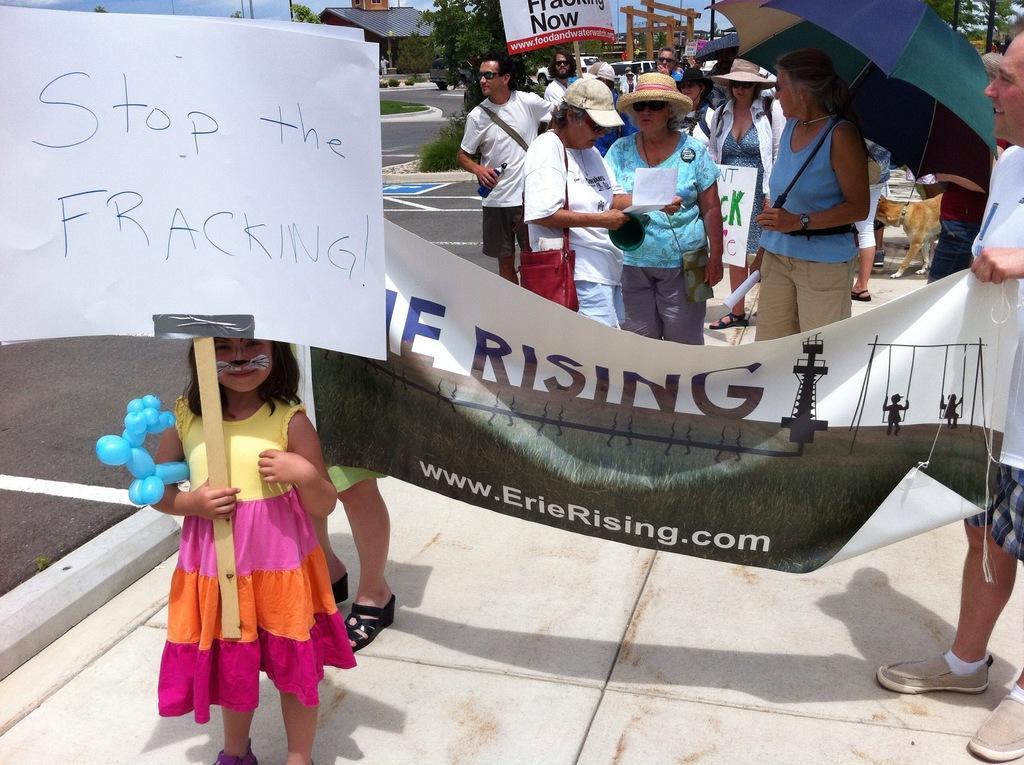Describe this image in one or two sentences. In the image few people are standing and holding some banners and umbrellas and papers. Behind them there are some trees and poles and buildings. 